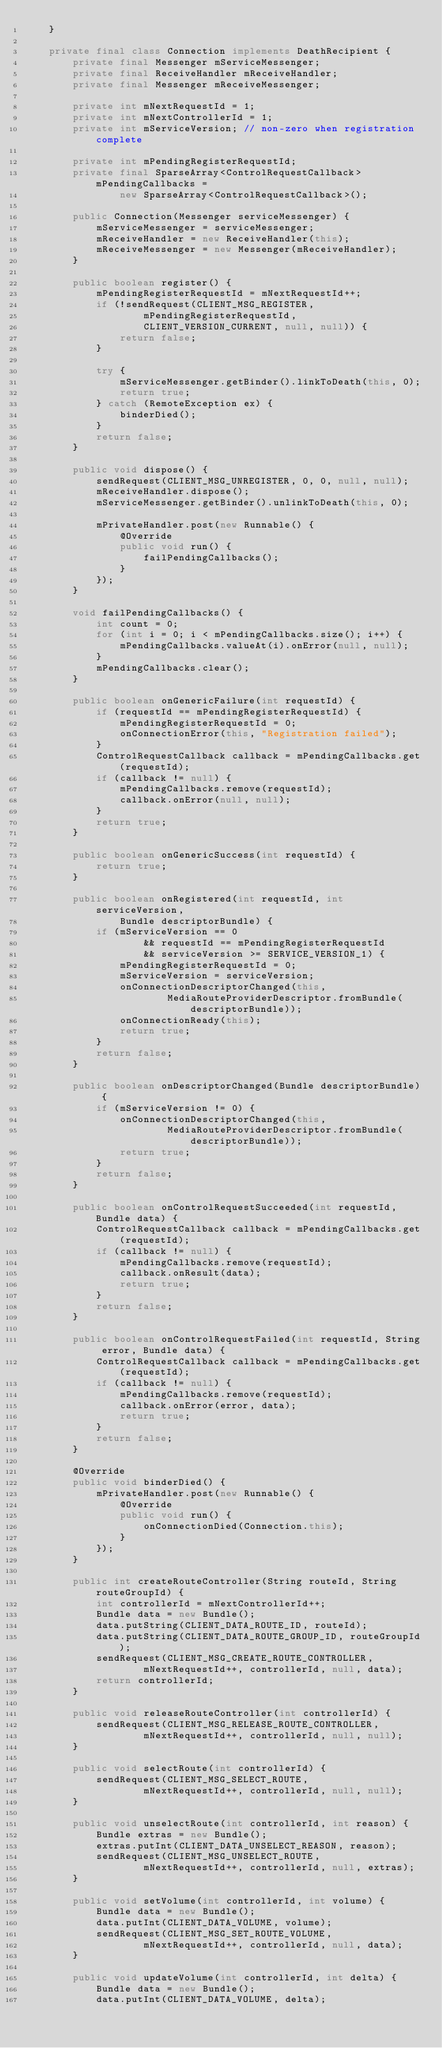<code> <loc_0><loc_0><loc_500><loc_500><_Java_>    }

    private final class Connection implements DeathRecipient {
        private final Messenger mServiceMessenger;
        private final ReceiveHandler mReceiveHandler;
        private final Messenger mReceiveMessenger;

        private int mNextRequestId = 1;
        private int mNextControllerId = 1;
        private int mServiceVersion; // non-zero when registration complete

        private int mPendingRegisterRequestId;
        private final SparseArray<ControlRequestCallback> mPendingCallbacks =
                new SparseArray<ControlRequestCallback>();

        public Connection(Messenger serviceMessenger) {
            mServiceMessenger = serviceMessenger;
            mReceiveHandler = new ReceiveHandler(this);
            mReceiveMessenger = new Messenger(mReceiveHandler);
        }

        public boolean register() {
            mPendingRegisterRequestId = mNextRequestId++;
            if (!sendRequest(CLIENT_MSG_REGISTER,
                    mPendingRegisterRequestId,
                    CLIENT_VERSION_CURRENT, null, null)) {
                return false;
            }

            try {
                mServiceMessenger.getBinder().linkToDeath(this, 0);
                return true;
            } catch (RemoteException ex) {
                binderDied();
            }
            return false;
        }

        public void dispose() {
            sendRequest(CLIENT_MSG_UNREGISTER, 0, 0, null, null);
            mReceiveHandler.dispose();
            mServiceMessenger.getBinder().unlinkToDeath(this, 0);

            mPrivateHandler.post(new Runnable() {
                @Override
                public void run() {
                    failPendingCallbacks();
                }
            });
        }

        void failPendingCallbacks() {
            int count = 0;
            for (int i = 0; i < mPendingCallbacks.size(); i++) {
                mPendingCallbacks.valueAt(i).onError(null, null);
            }
            mPendingCallbacks.clear();
        }

        public boolean onGenericFailure(int requestId) {
            if (requestId == mPendingRegisterRequestId) {
                mPendingRegisterRequestId = 0;
                onConnectionError(this, "Registration failed");
            }
            ControlRequestCallback callback = mPendingCallbacks.get(requestId);
            if (callback != null) {
                mPendingCallbacks.remove(requestId);
                callback.onError(null, null);
            }
            return true;
        }

        public boolean onGenericSuccess(int requestId) {
            return true;
        }

        public boolean onRegistered(int requestId, int serviceVersion,
                Bundle descriptorBundle) {
            if (mServiceVersion == 0
                    && requestId == mPendingRegisterRequestId
                    && serviceVersion >= SERVICE_VERSION_1) {
                mPendingRegisterRequestId = 0;
                mServiceVersion = serviceVersion;
                onConnectionDescriptorChanged(this,
                        MediaRouteProviderDescriptor.fromBundle(descriptorBundle));
                onConnectionReady(this);
                return true;
            }
            return false;
        }

        public boolean onDescriptorChanged(Bundle descriptorBundle) {
            if (mServiceVersion != 0) {
                onConnectionDescriptorChanged(this,
                        MediaRouteProviderDescriptor.fromBundle(descriptorBundle));
                return true;
            }
            return false;
        }

        public boolean onControlRequestSucceeded(int requestId, Bundle data) {
            ControlRequestCallback callback = mPendingCallbacks.get(requestId);
            if (callback != null) {
                mPendingCallbacks.remove(requestId);
                callback.onResult(data);
                return true;
            }
            return false;
        }

        public boolean onControlRequestFailed(int requestId, String error, Bundle data) {
            ControlRequestCallback callback = mPendingCallbacks.get(requestId);
            if (callback != null) {
                mPendingCallbacks.remove(requestId);
                callback.onError(error, data);
                return true;
            }
            return false;
        }

        @Override
        public void binderDied() {
            mPrivateHandler.post(new Runnable() {
                @Override
                public void run() {
                    onConnectionDied(Connection.this);
                }
            });
        }

        public int createRouteController(String routeId, String routeGroupId) {
            int controllerId = mNextControllerId++;
            Bundle data = new Bundle();
            data.putString(CLIENT_DATA_ROUTE_ID, routeId);
            data.putString(CLIENT_DATA_ROUTE_GROUP_ID, routeGroupId);
            sendRequest(CLIENT_MSG_CREATE_ROUTE_CONTROLLER,
                    mNextRequestId++, controllerId, null, data);
            return controllerId;
        }

        public void releaseRouteController(int controllerId) {
            sendRequest(CLIENT_MSG_RELEASE_ROUTE_CONTROLLER,
                    mNextRequestId++, controllerId, null, null);
        }

        public void selectRoute(int controllerId) {
            sendRequest(CLIENT_MSG_SELECT_ROUTE,
                    mNextRequestId++, controllerId, null, null);
        }

        public void unselectRoute(int controllerId, int reason) {
            Bundle extras = new Bundle();
            extras.putInt(CLIENT_DATA_UNSELECT_REASON, reason);
            sendRequest(CLIENT_MSG_UNSELECT_ROUTE,
                    mNextRequestId++, controllerId, null, extras);
        }

        public void setVolume(int controllerId, int volume) {
            Bundle data = new Bundle();
            data.putInt(CLIENT_DATA_VOLUME, volume);
            sendRequest(CLIENT_MSG_SET_ROUTE_VOLUME,
                    mNextRequestId++, controllerId, null, data);
        }

        public void updateVolume(int controllerId, int delta) {
            Bundle data = new Bundle();
            data.putInt(CLIENT_DATA_VOLUME, delta);</code> 